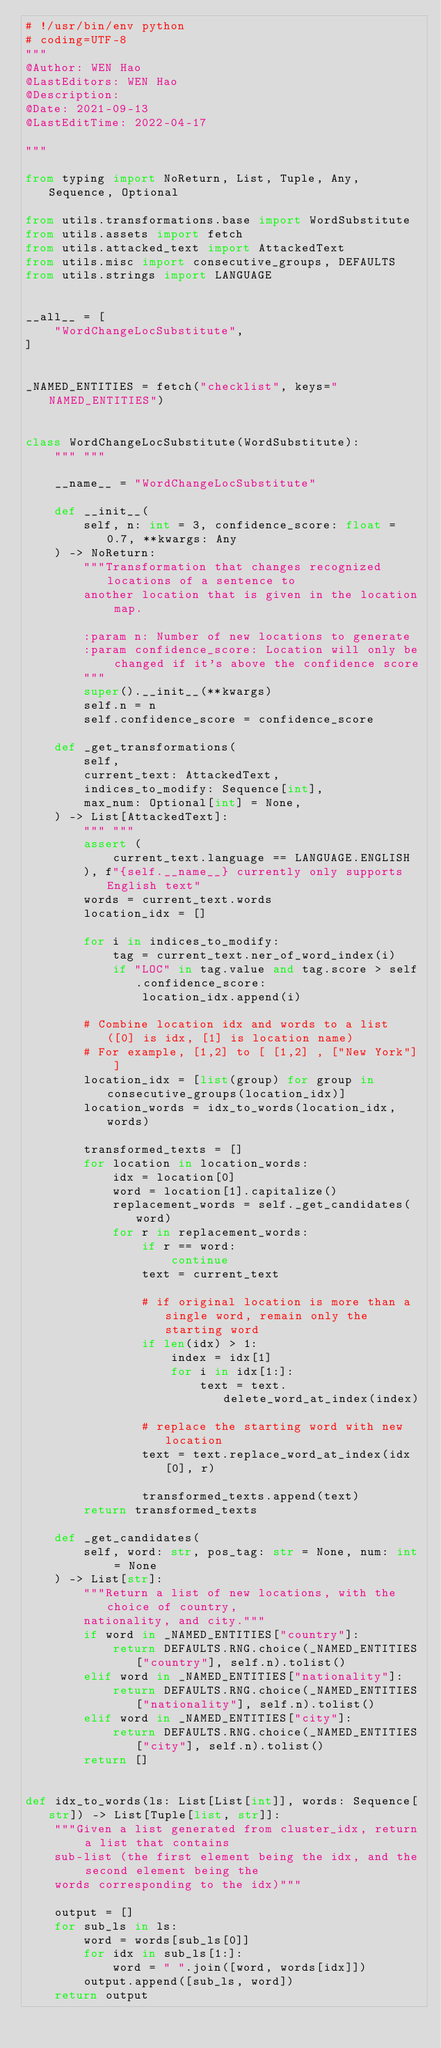<code> <loc_0><loc_0><loc_500><loc_500><_Python_># !/usr/bin/env python
# coding=UTF-8
"""
@Author: WEN Hao
@LastEditors: WEN Hao
@Description:
@Date: 2021-09-13
@LastEditTime: 2022-04-17

"""

from typing import NoReturn, List, Tuple, Any, Sequence, Optional

from utils.transformations.base import WordSubstitute
from utils.assets import fetch
from utils.attacked_text import AttackedText
from utils.misc import consecutive_groups, DEFAULTS
from utils.strings import LANGUAGE


__all__ = [
    "WordChangeLocSubstitute",
]


_NAMED_ENTITIES = fetch("checklist", keys="NAMED_ENTITIES")


class WordChangeLocSubstitute(WordSubstitute):
    """ """

    __name__ = "WordChangeLocSubstitute"

    def __init__(
        self, n: int = 3, confidence_score: float = 0.7, **kwargs: Any
    ) -> NoReturn:
        """Transformation that changes recognized locations of a sentence to
        another location that is given in the location map.

        :param n: Number of new locations to generate
        :param confidence_score: Location will only be changed if it's above the confidence score
        """
        super().__init__(**kwargs)
        self.n = n
        self.confidence_score = confidence_score

    def _get_transformations(
        self,
        current_text: AttackedText,
        indices_to_modify: Sequence[int],
        max_num: Optional[int] = None,
    ) -> List[AttackedText]:
        """ """
        assert (
            current_text.language == LANGUAGE.ENGLISH
        ), f"{self.__name__} currently only supports English text"
        words = current_text.words
        location_idx = []

        for i in indices_to_modify:
            tag = current_text.ner_of_word_index(i)
            if "LOC" in tag.value and tag.score > self.confidence_score:
                location_idx.append(i)

        # Combine location idx and words to a list ([0] is idx, [1] is location name)
        # For example, [1,2] to [ [1,2] , ["New York"] ]
        location_idx = [list(group) for group in consecutive_groups(location_idx)]
        location_words = idx_to_words(location_idx, words)

        transformed_texts = []
        for location in location_words:
            idx = location[0]
            word = location[1].capitalize()
            replacement_words = self._get_candidates(word)
            for r in replacement_words:
                if r == word:
                    continue
                text = current_text

                # if original location is more than a single word, remain only the starting word
                if len(idx) > 1:
                    index = idx[1]
                    for i in idx[1:]:
                        text = text.delete_word_at_index(index)

                # replace the starting word with new location
                text = text.replace_word_at_index(idx[0], r)

                transformed_texts.append(text)
        return transformed_texts

    def _get_candidates(
        self, word: str, pos_tag: str = None, num: int = None
    ) -> List[str]:
        """Return a list of new locations, with the choice of country,
        nationality, and city."""
        if word in _NAMED_ENTITIES["country"]:
            return DEFAULTS.RNG.choice(_NAMED_ENTITIES["country"], self.n).tolist()
        elif word in _NAMED_ENTITIES["nationality"]:
            return DEFAULTS.RNG.choice(_NAMED_ENTITIES["nationality"], self.n).tolist()
        elif word in _NAMED_ENTITIES["city"]:
            return DEFAULTS.RNG.choice(_NAMED_ENTITIES["city"], self.n).tolist()
        return []


def idx_to_words(ls: List[List[int]], words: Sequence[str]) -> List[Tuple[list, str]]:
    """Given a list generated from cluster_idx, return a list that contains
    sub-list (the first element being the idx, and the second element being the
    words corresponding to the idx)"""

    output = []
    for sub_ls in ls:
        word = words[sub_ls[0]]
        for idx in sub_ls[1:]:
            word = " ".join([word, words[idx]])
        output.append([sub_ls, word])
    return output
</code> 